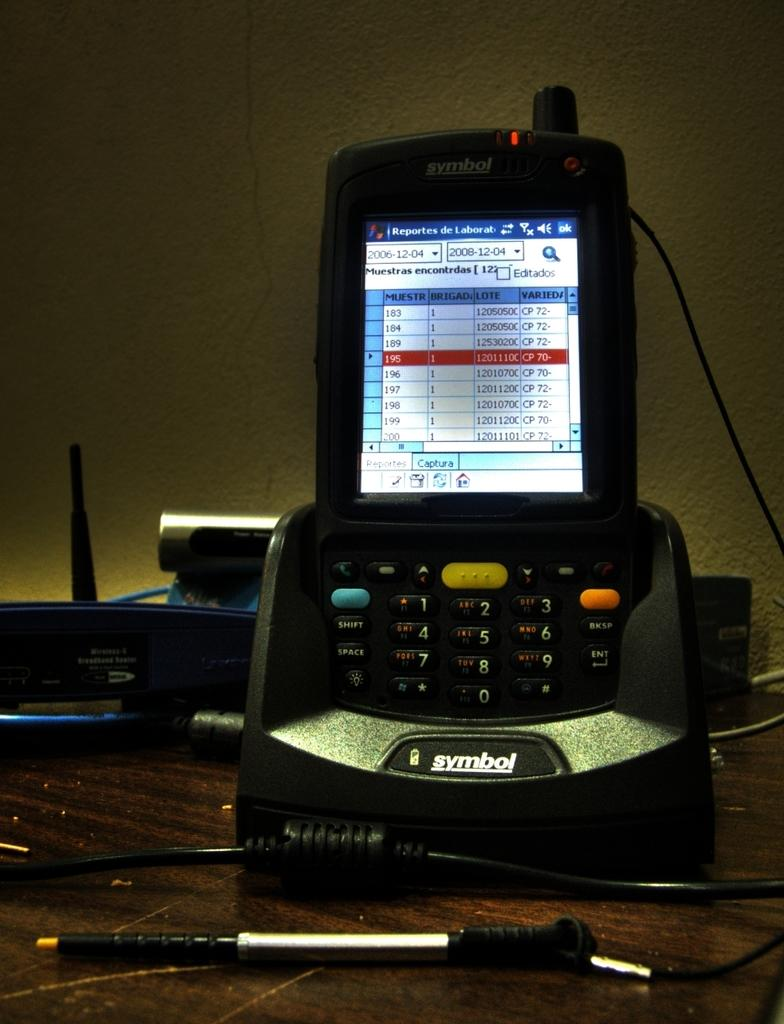What type of objects can be seen in the image? There are electronic devices in the image. What is connected to the electronic devices? There is a cable wire in the image. What material is the surface that the electronic devices are placed on? There is a wooden surface in the image. What is visible in the background of the image? There is a wall in the image. What caption is written on the geese in the image? There are no geese present in the image, and therefore no caption can be found on them. 